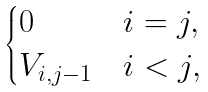<formula> <loc_0><loc_0><loc_500><loc_500>\begin{cases} 0 & i = j , \\ V _ { i , j - 1 } & i < j , \end{cases}</formula> 